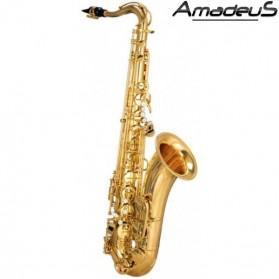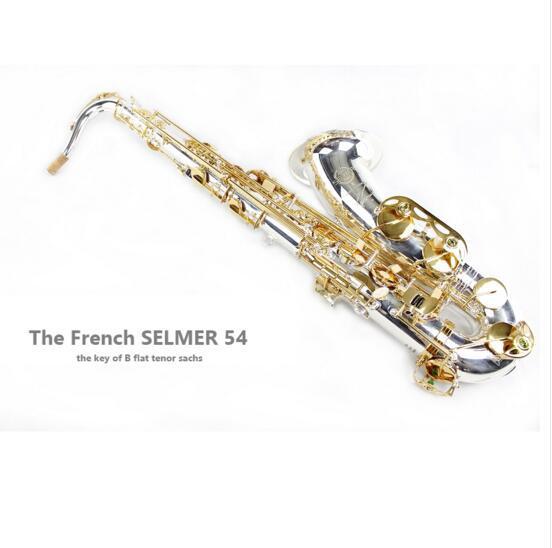The first image is the image on the left, the second image is the image on the right. Considering the images on both sides, is "The entire saxophone is visible in each image." valid? Answer yes or no. Yes. The first image is the image on the left, the second image is the image on the right. Analyze the images presented: Is the assertion "An image shows a right-facing saxophone displayed vertically." valid? Answer yes or no. Yes. 